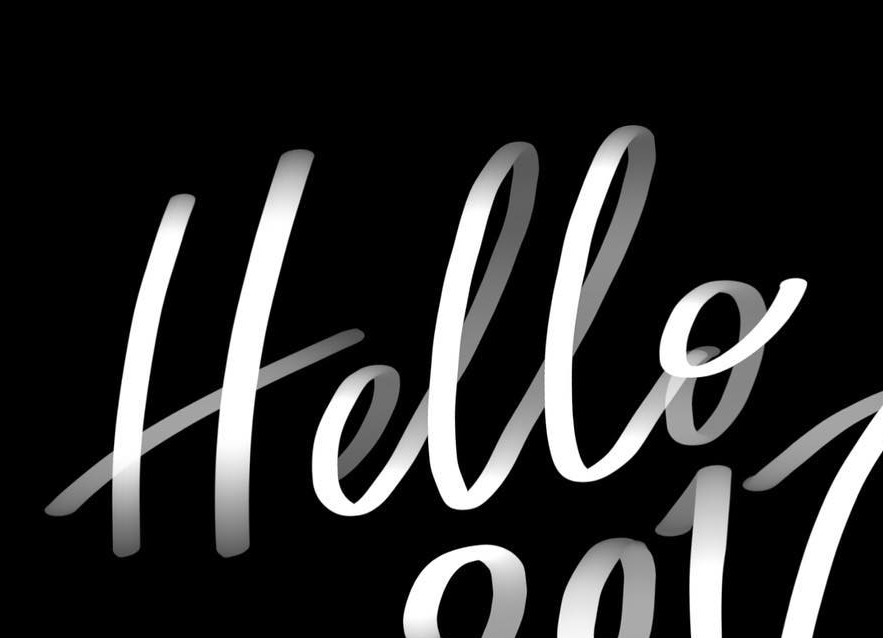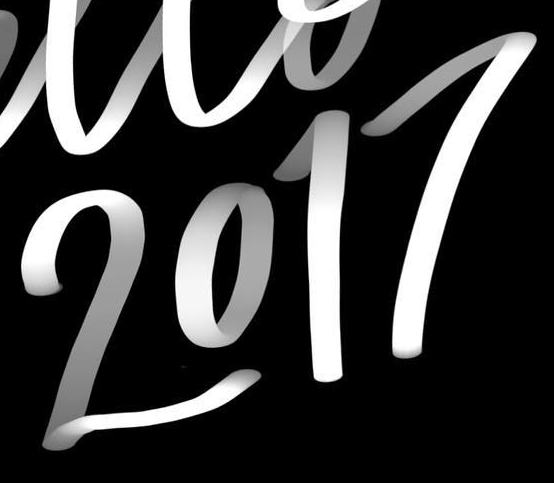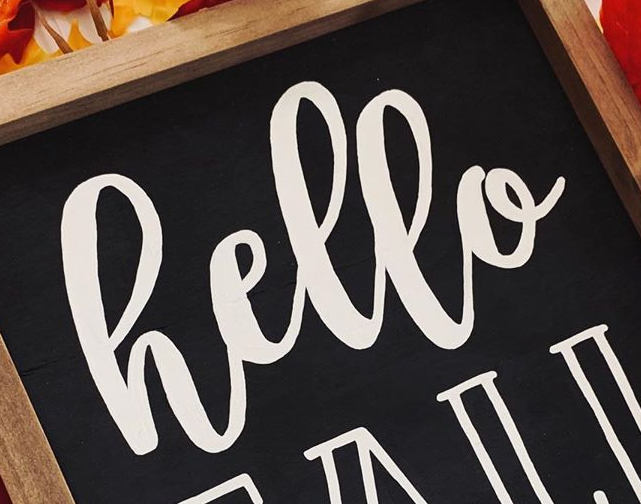What text is displayed in these images sequentially, separated by a semicolon? Hello; 2017; hello 